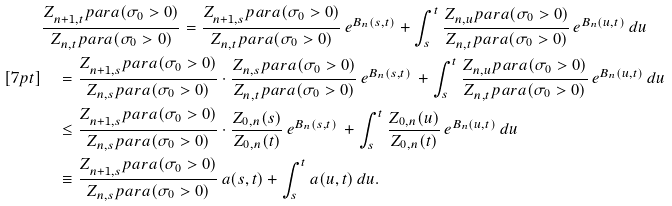Convert formula to latex. <formula><loc_0><loc_0><loc_500><loc_500>& \frac { Z _ { n + 1 , t } ^ { \ } p a r a ( \sigma _ { 0 } > 0 ) } { Z _ { n , t } ^ { \ } p a r a ( \sigma _ { 0 } > 0 ) } = \frac { Z _ { n + 1 , s } ^ { \ } p a r a ( \sigma _ { 0 } > 0 ) } { Z _ { n , t } ^ { \ } p a r a ( \sigma _ { 0 } > 0 ) } \, e ^ { B _ { n } ( s , t ) } + \int _ { s } ^ { t } \frac { Z _ { n , u } ^ { \ } p a r a ( \sigma _ { 0 } > 0 ) } { Z _ { n , t } ^ { \ } p a r a ( \sigma _ { 0 } > 0 ) } \, e ^ { B _ { n } ( u , t ) } \, d u \\ [ 7 p t ] & \quad = \frac { Z _ { n + 1 , s } ^ { \ } p a r a ( \sigma _ { 0 } > 0 ) } { Z _ { n , s } ^ { \ } p a r a ( \sigma _ { 0 } > 0 ) } \cdot \frac { Z _ { n , s } ^ { \ } p a r a ( \sigma _ { 0 } > 0 ) } { Z _ { n , t } ^ { \ } p a r a ( \sigma _ { 0 } > 0 ) } \, e ^ { B _ { n } ( s , t ) } \, + \int _ { s } ^ { t } \frac { Z _ { n , u } ^ { \ } p a r a ( \sigma _ { 0 } > 0 ) } { Z _ { n , t } ^ { \ } p a r a ( \sigma _ { 0 } > 0 ) } \, e ^ { B _ { n } ( u , t ) } \, d u \\ & \quad \leq \frac { Z _ { n + 1 , s } ^ { \ } p a r a ( \sigma _ { 0 } > 0 ) } { Z _ { n , s } ^ { \ } p a r a ( \sigma _ { 0 } > 0 ) } \cdot \frac { Z _ { 0 , n } ( s ) } { Z _ { 0 , n } ( t ) } \, e ^ { B _ { n } ( s , t ) } \, + \int _ { s } ^ { t } \frac { Z _ { 0 , n } ( u ) } { Z _ { 0 , n } ( t ) } \, e ^ { B _ { n } ( u , t ) } \, d u \\ & \quad \equiv \frac { Z _ { n + 1 , s } ^ { \ } p a r a ( \sigma _ { 0 } > 0 ) } { Z _ { n , s } ^ { \ } p a r a ( \sigma _ { 0 } > 0 ) } \, a ( s , t ) + \int _ { s } ^ { t } a ( u , t ) \, d u .</formula> 